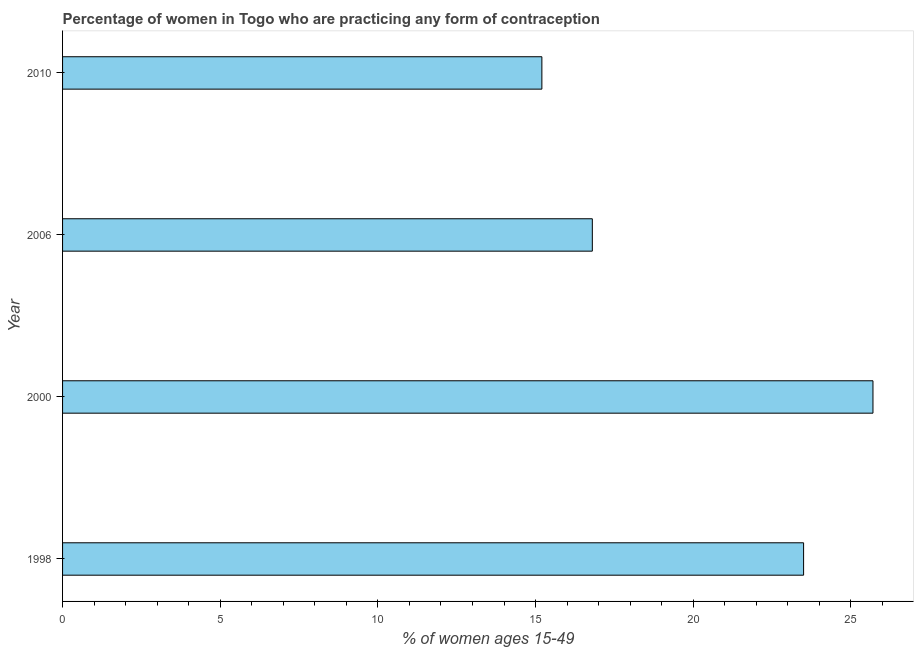Does the graph contain any zero values?
Your answer should be very brief. No. What is the title of the graph?
Ensure brevity in your answer.  Percentage of women in Togo who are practicing any form of contraception. What is the label or title of the X-axis?
Offer a very short reply. % of women ages 15-49. What is the contraceptive prevalence in 2000?
Your answer should be compact. 25.7. Across all years, what is the maximum contraceptive prevalence?
Keep it short and to the point. 25.7. Across all years, what is the minimum contraceptive prevalence?
Keep it short and to the point. 15.2. What is the sum of the contraceptive prevalence?
Your response must be concise. 81.2. What is the average contraceptive prevalence per year?
Keep it short and to the point. 20.3. What is the median contraceptive prevalence?
Offer a terse response. 20.15. In how many years, is the contraceptive prevalence greater than 5 %?
Give a very brief answer. 4. What is the ratio of the contraceptive prevalence in 1998 to that in 2010?
Offer a terse response. 1.55. Is the difference between the contraceptive prevalence in 2000 and 2006 greater than the difference between any two years?
Give a very brief answer. No. What is the difference between the highest and the second highest contraceptive prevalence?
Give a very brief answer. 2.2. What is the difference between the highest and the lowest contraceptive prevalence?
Your response must be concise. 10.5. How many bars are there?
Your answer should be compact. 4. Are all the bars in the graph horizontal?
Offer a terse response. Yes. How many years are there in the graph?
Offer a very short reply. 4. What is the % of women ages 15-49 of 1998?
Your answer should be very brief. 23.5. What is the % of women ages 15-49 of 2000?
Your response must be concise. 25.7. What is the difference between the % of women ages 15-49 in 1998 and 2010?
Provide a succinct answer. 8.3. What is the ratio of the % of women ages 15-49 in 1998 to that in 2000?
Make the answer very short. 0.91. What is the ratio of the % of women ages 15-49 in 1998 to that in 2006?
Keep it short and to the point. 1.4. What is the ratio of the % of women ages 15-49 in 1998 to that in 2010?
Provide a succinct answer. 1.55. What is the ratio of the % of women ages 15-49 in 2000 to that in 2006?
Your answer should be compact. 1.53. What is the ratio of the % of women ages 15-49 in 2000 to that in 2010?
Give a very brief answer. 1.69. What is the ratio of the % of women ages 15-49 in 2006 to that in 2010?
Make the answer very short. 1.1. 